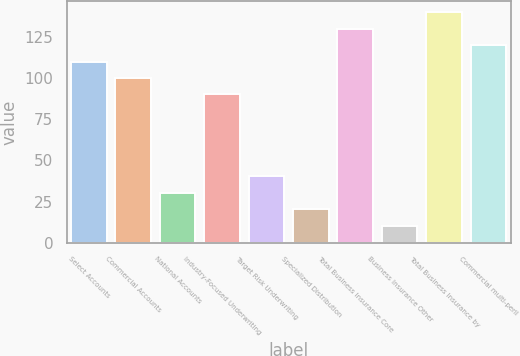<chart> <loc_0><loc_0><loc_500><loc_500><bar_chart><fcel>Select Accounts<fcel>Commercial Accounts<fcel>National Accounts<fcel>Industry-Focused Underwriting<fcel>Target Risk Underwriting<fcel>Specialized Distribution<fcel>Total Business Insurance Core<fcel>Business Insurance Other<fcel>Total Business Insurance by<fcel>Commercial multi-peril<nl><fcel>109.96<fcel>100<fcel>30.28<fcel>90.04<fcel>40.24<fcel>20.32<fcel>129.88<fcel>10.36<fcel>139.84<fcel>119.92<nl></chart> 